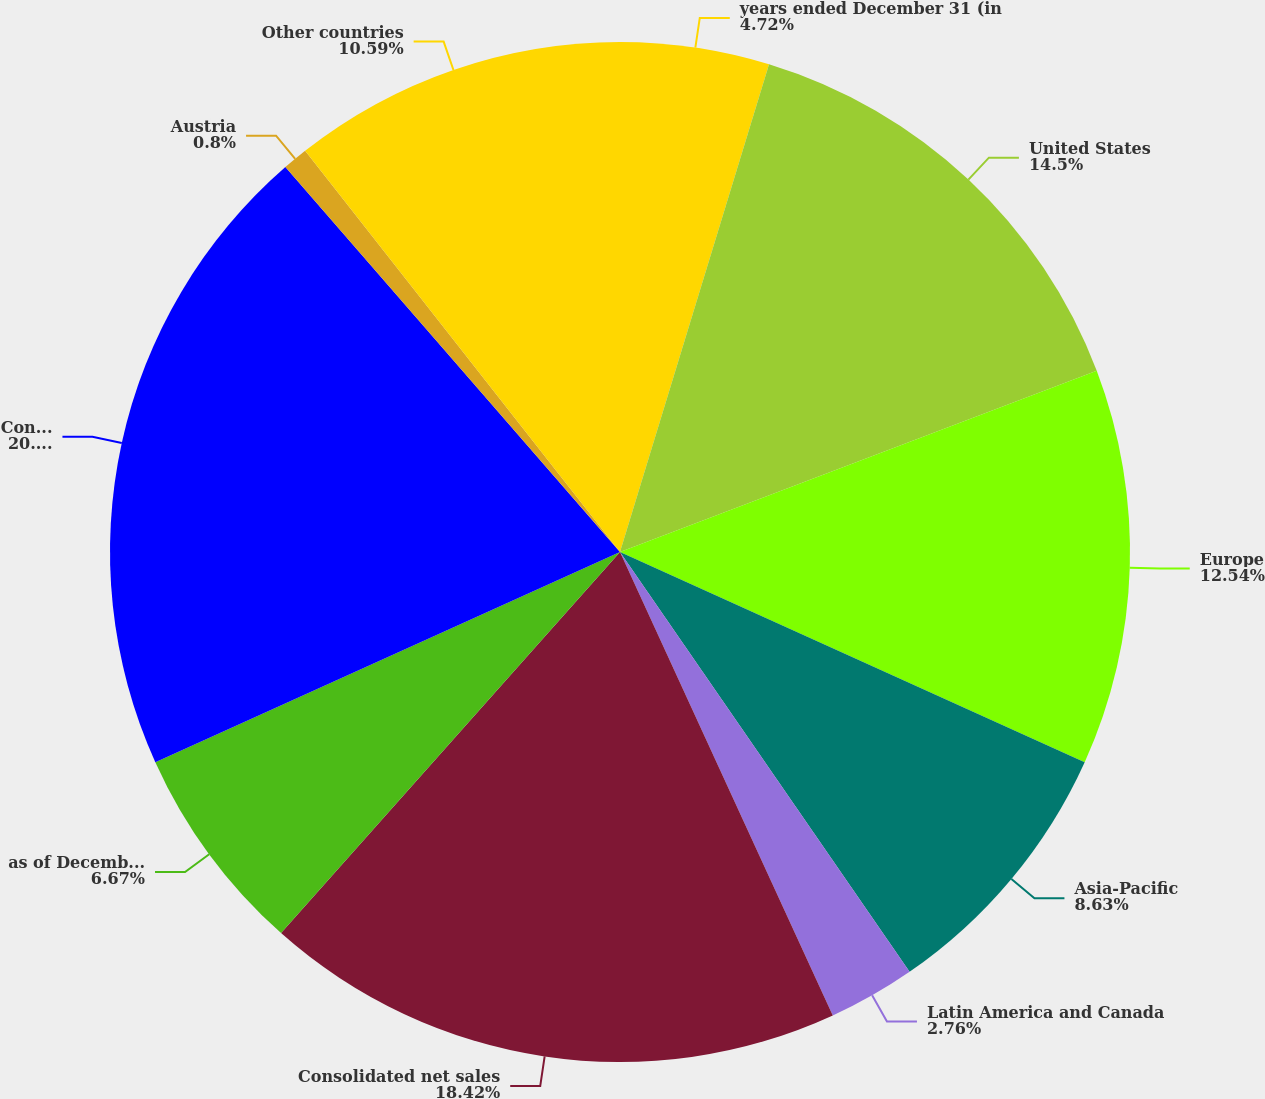Convert chart to OTSL. <chart><loc_0><loc_0><loc_500><loc_500><pie_chart><fcel>years ended December 31 (in<fcel>United States<fcel>Europe<fcel>Asia-Pacific<fcel>Latin America and Canada<fcel>Consolidated net sales<fcel>as of December 31 (in<fcel>Consolidated total assets<fcel>Austria<fcel>Other countries<nl><fcel>4.72%<fcel>14.5%<fcel>12.54%<fcel>8.63%<fcel>2.76%<fcel>18.42%<fcel>6.67%<fcel>20.37%<fcel>0.8%<fcel>10.59%<nl></chart> 